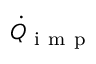<formula> <loc_0><loc_0><loc_500><loc_500>\dot { Q } _ { i m p }</formula> 